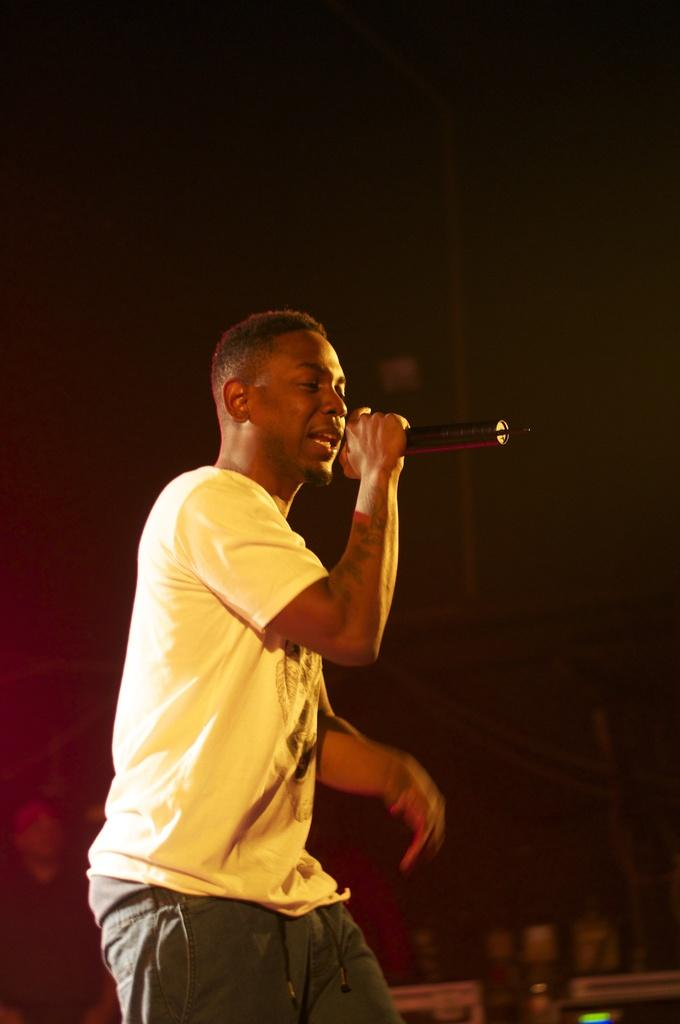Who is the main subject in the image? There is a man in the image. What is the man wearing? The man is wearing a yellow t-shirt. What is the man holding in his hand? The man is holding a microphone in his hand. What type of instrument is the man playing in the image? There is no instrument present in the image; the man is holding a microphone. What industry does the man work in, as indicated by his attire? There is no information about the man's industry or occupation in the image, only the color of his t-shirt. 